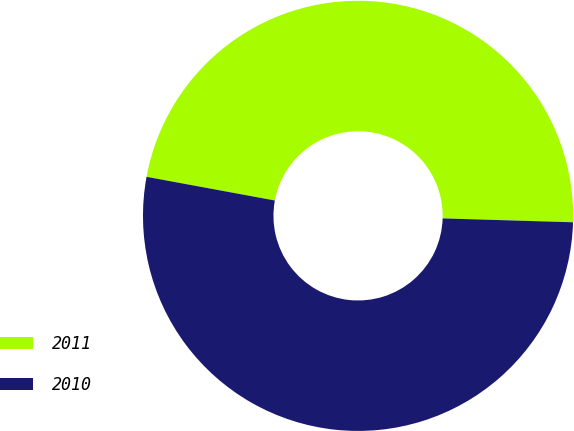<chart> <loc_0><loc_0><loc_500><loc_500><pie_chart><fcel>2011<fcel>2010<nl><fcel>47.57%<fcel>52.43%<nl></chart> 